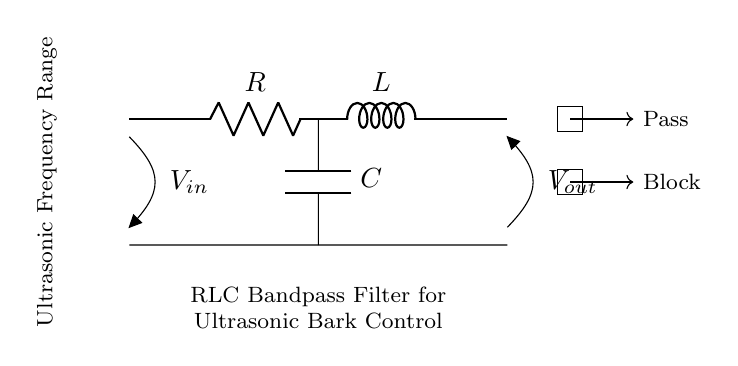What components are in this circuit? The circuit contains a resistor, an inductor, and a capacitor which are depicted in the diagram.
Answer: Resistor, inductor, capacitor What is the purpose of the RLC circuit in this context? The RLC circuit serves as a bandpass filter to allow ultrasonic frequencies to pass while blocking others, as indicated in the notes and directional arrows.
Answer: Bandpass filter What is the function of the resistor in this RLC circuit? The resistor limits the current in the circuit and influences the overall impedance, which affects the filter's bandwidth and quality.
Answer: Limits current What frequencies does this bandpass filter allow? The filter allows ultrasonic frequencies, as explicitly noted in the circuit diagram's accompanying label.
Answer: Ultrasonic frequencies How does the capacitor affect the filter behavior? The capacitor, in combination with the resistor and inductor, determines the cutoff frequencies of the filter, thus shaping the response to specific frequency ranges.
Answer: Determines cutoff frequencies What does the rectangle labeled "Pass" represent? The "Pass" rectangle indicates the portion of the frequency spectrum that the filter allows through to the output.
Answer: Allowed frequencies What role does the inductor play in this circuit? The inductor stores energy in a magnetic field and, along with the capacitor and resistor, contributes to the frequency response of the bandpass filter.
Answer: Stores energy 